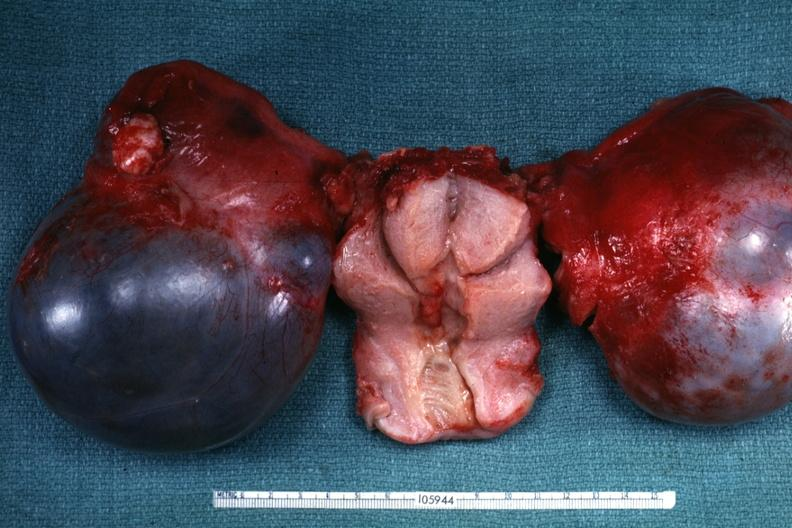what is cystadenocarcinoma malignancy?
Answer the question using a single word or phrase. Not obvious from gross appearance 